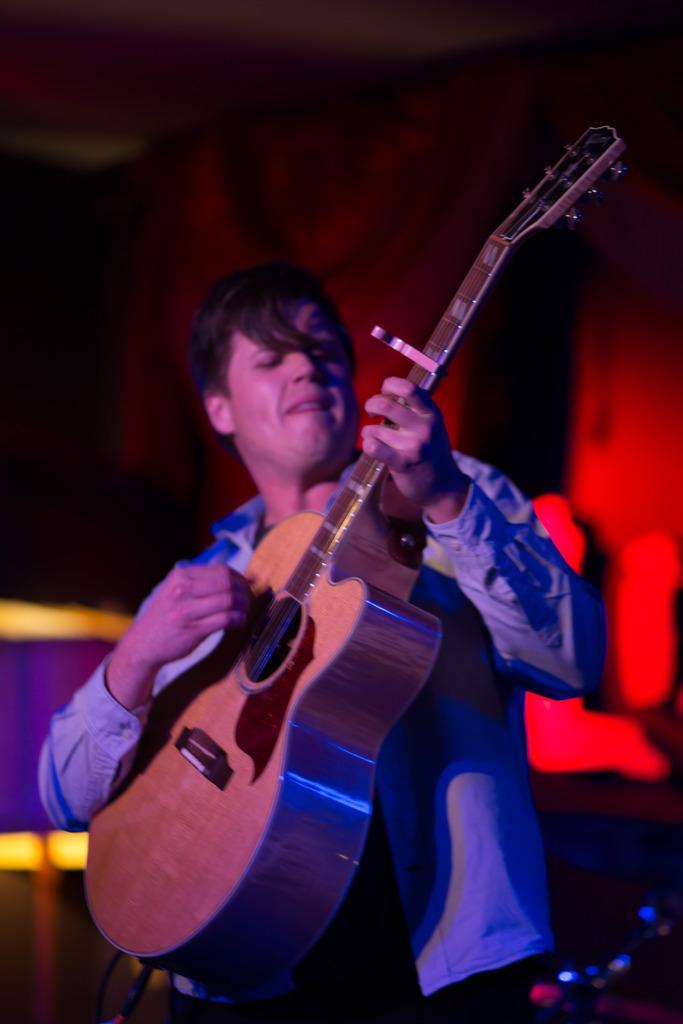Please provide a concise description of this image. in this image and in this stage one person is playing the guitar and back ground is very red and the person is wearing blue shirt and pant. 